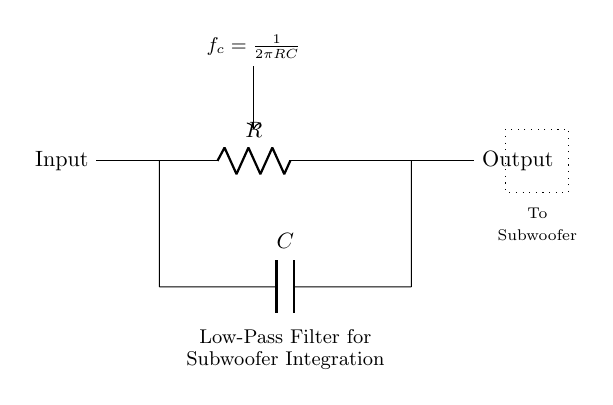What type of filter is shown in the diagram? The circuit diagram clearly shows a low-pass filter, which is indicated by its configuration with a resistor and capacitor. Low-pass filters allow signals with a frequency lower than a certain cutoff frequency to pass through while attenuating higher frequencies.
Answer: low-pass filter What is the output of the circuit labeled as? The circuit output is explicitly marked as "Output" on the right side of the diagram, indicating where the filtered signal is taken from.
Answer: Output What is the role of the component connected in parallel to the resistor? The component in parallel to the resistor is a capacitor, as indicated in the diagram. Capacitors in low-pass filters are crucial for allowing low-frequency signals to pass while blocking higher frequencies.
Answer: capacitor What is the formula for the cutoff frequency in this circuit? The formula provided in the circuit states that the cutoff frequency, denoted as "f_c," is equal to the reciprocal of the product of 2, pi, R, and C. This formula is essential for determining at which frequency the filter will start to attenuate signals.
Answer: f_c = 1/(2πRC) How does increasing the value of the resistor affect the cutoff frequency? Increasing the resistance value (R) lowers the cutoff frequency (f_c) based on the formula f_c = 1/(2πRC). This means that with a higher resistor value, the filter will allow lower frequencies to pass through effectively while attenuating higher frequencies sooner.
Answer: decreases cutoff frequency What happens to the filtered signal before it reaches the subwoofer? The dotted box indicates that the signal, after passing through the low-pass filter, is sent to a subwoofer, where it is expected that low-frequency sounds will be emphasized while higher frequencies are reduced. This is critical for effective subwoofer integration into a PA system.
Answer: to subwoofer 